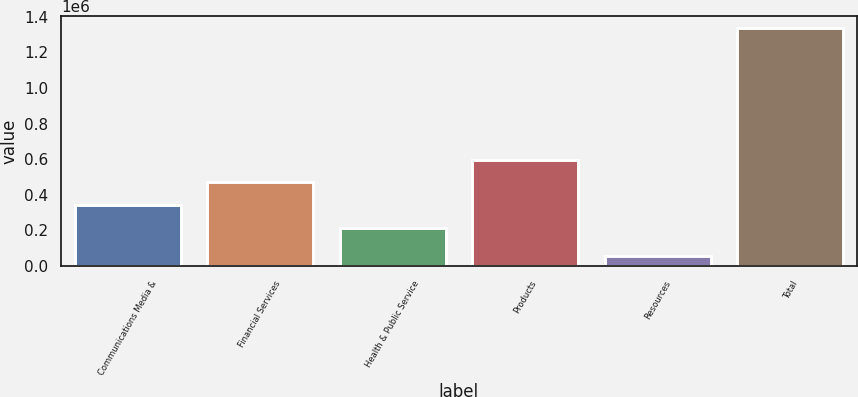<chart> <loc_0><loc_0><loc_500><loc_500><bar_chart><fcel>Communications Media &<fcel>Financial Services<fcel>Health & Public Service<fcel>Products<fcel>Resources<fcel>Total<nl><fcel>342297<fcel>470278<fcel>214316<fcel>598259<fcel>56447<fcel>1.33626e+06<nl></chart> 